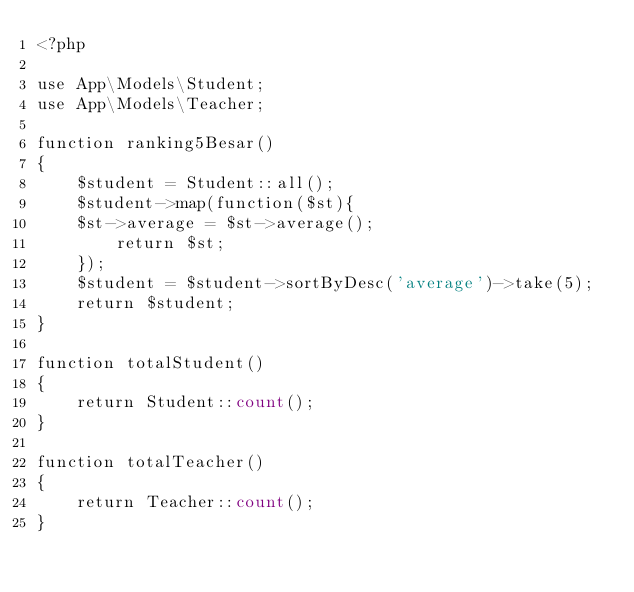<code> <loc_0><loc_0><loc_500><loc_500><_PHP_><?php

use App\Models\Student;
use App\Models\Teacher;

function ranking5Besar()
{
    $student = Student::all();
    $student->map(function($st){
    $st->average = $st->average();
        return $st;
    });
    $student = $student->sortByDesc('average')->take(5);
    return $student;
}

function totalStudent()
{
    return Student::count();
}

function totalTeacher()
{
    return Teacher::count();
}</code> 